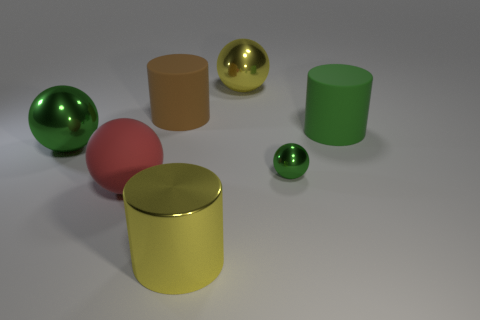Does the yellow ball have the same size as the green sphere left of the big brown rubber cylinder?
Keep it short and to the point. Yes. What is the shape of the large green object that is left of the big yellow thing in front of the large thing that is to the right of the tiny green ball?
Offer a terse response. Sphere. Is the number of big yellow objects less than the number of small green shiny things?
Ensure brevity in your answer.  No. There is a large yellow shiny cylinder; are there any matte objects on the left side of it?
Your answer should be very brief. Yes. What is the shape of the shiny object that is in front of the brown cylinder and on the right side of the big yellow cylinder?
Give a very brief answer. Sphere. Is there a large yellow thing of the same shape as the red matte thing?
Offer a terse response. Yes. There is a green metallic ball that is to the left of the large brown cylinder; is its size the same as the green ball that is on the right side of the yellow shiny cylinder?
Your answer should be compact. No. Are there more green things than red matte spheres?
Offer a terse response. Yes. What number of small spheres are made of the same material as the large red sphere?
Provide a short and direct response. 0. Does the big red thing have the same shape as the small thing?
Your response must be concise. Yes. 